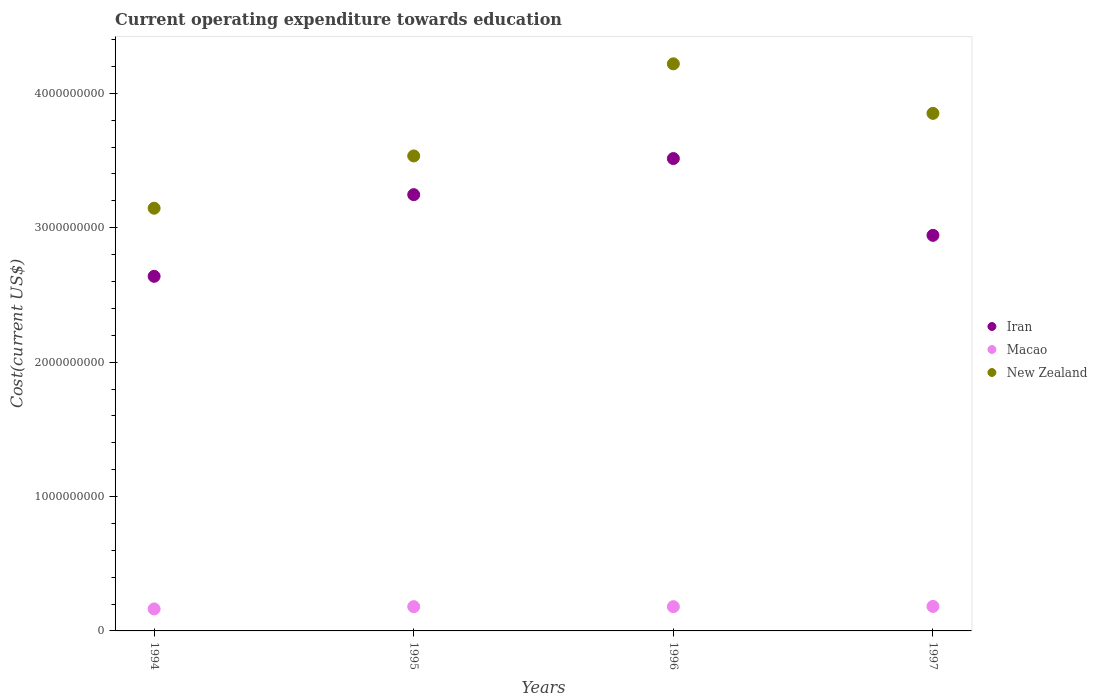What is the expenditure towards education in Macao in 1996?
Make the answer very short. 1.80e+08. Across all years, what is the maximum expenditure towards education in Iran?
Keep it short and to the point. 3.51e+09. Across all years, what is the minimum expenditure towards education in Macao?
Your answer should be very brief. 1.64e+08. What is the total expenditure towards education in New Zealand in the graph?
Your answer should be very brief. 1.48e+1. What is the difference between the expenditure towards education in New Zealand in 1994 and that in 1995?
Offer a terse response. -3.89e+08. What is the difference between the expenditure towards education in Macao in 1994 and the expenditure towards education in Iran in 1997?
Offer a very short reply. -2.78e+09. What is the average expenditure towards education in New Zealand per year?
Offer a terse response. 3.69e+09. In the year 1997, what is the difference between the expenditure towards education in Iran and expenditure towards education in New Zealand?
Your answer should be very brief. -9.08e+08. What is the ratio of the expenditure towards education in New Zealand in 1995 to that in 1996?
Ensure brevity in your answer.  0.84. What is the difference between the highest and the second highest expenditure towards education in New Zealand?
Provide a succinct answer. 3.69e+08. What is the difference between the highest and the lowest expenditure towards education in Iran?
Ensure brevity in your answer.  8.76e+08. In how many years, is the expenditure towards education in Iran greater than the average expenditure towards education in Iran taken over all years?
Make the answer very short. 2. Is the sum of the expenditure towards education in New Zealand in 1994 and 1996 greater than the maximum expenditure towards education in Iran across all years?
Keep it short and to the point. Yes. Is it the case that in every year, the sum of the expenditure towards education in New Zealand and expenditure towards education in Iran  is greater than the expenditure towards education in Macao?
Your answer should be compact. Yes. Does the expenditure towards education in Macao monotonically increase over the years?
Offer a very short reply. No. How many years are there in the graph?
Ensure brevity in your answer.  4. Does the graph contain grids?
Offer a terse response. No. How many legend labels are there?
Offer a terse response. 3. What is the title of the graph?
Give a very brief answer. Current operating expenditure towards education. What is the label or title of the Y-axis?
Give a very brief answer. Cost(current US$). What is the Cost(current US$) in Iran in 1994?
Offer a terse response. 2.64e+09. What is the Cost(current US$) of Macao in 1994?
Ensure brevity in your answer.  1.64e+08. What is the Cost(current US$) in New Zealand in 1994?
Offer a very short reply. 3.15e+09. What is the Cost(current US$) in Iran in 1995?
Your response must be concise. 3.25e+09. What is the Cost(current US$) in Macao in 1995?
Provide a short and direct response. 1.81e+08. What is the Cost(current US$) of New Zealand in 1995?
Provide a short and direct response. 3.53e+09. What is the Cost(current US$) of Iran in 1996?
Make the answer very short. 3.51e+09. What is the Cost(current US$) of Macao in 1996?
Keep it short and to the point. 1.80e+08. What is the Cost(current US$) of New Zealand in 1996?
Provide a succinct answer. 4.22e+09. What is the Cost(current US$) in Iran in 1997?
Provide a succinct answer. 2.94e+09. What is the Cost(current US$) of Macao in 1997?
Provide a succinct answer. 1.82e+08. What is the Cost(current US$) of New Zealand in 1997?
Offer a very short reply. 3.85e+09. Across all years, what is the maximum Cost(current US$) in Iran?
Ensure brevity in your answer.  3.51e+09. Across all years, what is the maximum Cost(current US$) of Macao?
Give a very brief answer. 1.82e+08. Across all years, what is the maximum Cost(current US$) of New Zealand?
Your response must be concise. 4.22e+09. Across all years, what is the minimum Cost(current US$) in Iran?
Your answer should be compact. 2.64e+09. Across all years, what is the minimum Cost(current US$) in Macao?
Your answer should be very brief. 1.64e+08. Across all years, what is the minimum Cost(current US$) of New Zealand?
Your response must be concise. 3.15e+09. What is the total Cost(current US$) of Iran in the graph?
Give a very brief answer. 1.23e+1. What is the total Cost(current US$) in Macao in the graph?
Offer a terse response. 7.07e+08. What is the total Cost(current US$) in New Zealand in the graph?
Offer a terse response. 1.48e+1. What is the difference between the Cost(current US$) in Iran in 1994 and that in 1995?
Your answer should be very brief. -6.08e+08. What is the difference between the Cost(current US$) of Macao in 1994 and that in 1995?
Give a very brief answer. -1.69e+07. What is the difference between the Cost(current US$) of New Zealand in 1994 and that in 1995?
Offer a very short reply. -3.89e+08. What is the difference between the Cost(current US$) in Iran in 1994 and that in 1996?
Your answer should be very brief. -8.76e+08. What is the difference between the Cost(current US$) in Macao in 1994 and that in 1996?
Your answer should be very brief. -1.68e+07. What is the difference between the Cost(current US$) in New Zealand in 1994 and that in 1996?
Offer a very short reply. -1.07e+09. What is the difference between the Cost(current US$) of Iran in 1994 and that in 1997?
Give a very brief answer. -3.05e+08. What is the difference between the Cost(current US$) in Macao in 1994 and that in 1997?
Ensure brevity in your answer.  -1.85e+07. What is the difference between the Cost(current US$) of New Zealand in 1994 and that in 1997?
Make the answer very short. -7.06e+08. What is the difference between the Cost(current US$) in Iran in 1995 and that in 1996?
Offer a terse response. -2.69e+08. What is the difference between the Cost(current US$) of Macao in 1995 and that in 1996?
Provide a short and direct response. 9.88e+04. What is the difference between the Cost(current US$) of New Zealand in 1995 and that in 1996?
Provide a short and direct response. -6.85e+08. What is the difference between the Cost(current US$) of Iran in 1995 and that in 1997?
Offer a terse response. 3.03e+08. What is the difference between the Cost(current US$) in Macao in 1995 and that in 1997?
Offer a terse response. -1.66e+06. What is the difference between the Cost(current US$) of New Zealand in 1995 and that in 1997?
Provide a short and direct response. -3.17e+08. What is the difference between the Cost(current US$) in Iran in 1996 and that in 1997?
Provide a short and direct response. 5.71e+08. What is the difference between the Cost(current US$) in Macao in 1996 and that in 1997?
Give a very brief answer. -1.76e+06. What is the difference between the Cost(current US$) in New Zealand in 1996 and that in 1997?
Your answer should be very brief. 3.69e+08. What is the difference between the Cost(current US$) in Iran in 1994 and the Cost(current US$) in Macao in 1995?
Offer a very short reply. 2.46e+09. What is the difference between the Cost(current US$) of Iran in 1994 and the Cost(current US$) of New Zealand in 1995?
Provide a succinct answer. -8.96e+08. What is the difference between the Cost(current US$) in Macao in 1994 and the Cost(current US$) in New Zealand in 1995?
Offer a very short reply. -3.37e+09. What is the difference between the Cost(current US$) of Iran in 1994 and the Cost(current US$) of Macao in 1996?
Provide a succinct answer. 2.46e+09. What is the difference between the Cost(current US$) in Iran in 1994 and the Cost(current US$) in New Zealand in 1996?
Ensure brevity in your answer.  -1.58e+09. What is the difference between the Cost(current US$) in Macao in 1994 and the Cost(current US$) in New Zealand in 1996?
Provide a succinct answer. -4.06e+09. What is the difference between the Cost(current US$) in Iran in 1994 and the Cost(current US$) in Macao in 1997?
Keep it short and to the point. 2.46e+09. What is the difference between the Cost(current US$) in Iran in 1994 and the Cost(current US$) in New Zealand in 1997?
Offer a very short reply. -1.21e+09. What is the difference between the Cost(current US$) in Macao in 1994 and the Cost(current US$) in New Zealand in 1997?
Make the answer very short. -3.69e+09. What is the difference between the Cost(current US$) of Iran in 1995 and the Cost(current US$) of Macao in 1996?
Keep it short and to the point. 3.07e+09. What is the difference between the Cost(current US$) in Iran in 1995 and the Cost(current US$) in New Zealand in 1996?
Keep it short and to the point. -9.73e+08. What is the difference between the Cost(current US$) of Macao in 1995 and the Cost(current US$) of New Zealand in 1996?
Make the answer very short. -4.04e+09. What is the difference between the Cost(current US$) in Iran in 1995 and the Cost(current US$) in Macao in 1997?
Offer a terse response. 3.06e+09. What is the difference between the Cost(current US$) in Iran in 1995 and the Cost(current US$) in New Zealand in 1997?
Your answer should be compact. -6.05e+08. What is the difference between the Cost(current US$) of Macao in 1995 and the Cost(current US$) of New Zealand in 1997?
Your answer should be very brief. -3.67e+09. What is the difference between the Cost(current US$) in Iran in 1996 and the Cost(current US$) in Macao in 1997?
Give a very brief answer. 3.33e+09. What is the difference between the Cost(current US$) of Iran in 1996 and the Cost(current US$) of New Zealand in 1997?
Give a very brief answer. -3.36e+08. What is the difference between the Cost(current US$) of Macao in 1996 and the Cost(current US$) of New Zealand in 1997?
Keep it short and to the point. -3.67e+09. What is the average Cost(current US$) in Iran per year?
Provide a short and direct response. 3.09e+09. What is the average Cost(current US$) of Macao per year?
Offer a terse response. 1.77e+08. What is the average Cost(current US$) of New Zealand per year?
Give a very brief answer. 3.69e+09. In the year 1994, what is the difference between the Cost(current US$) in Iran and Cost(current US$) in Macao?
Your response must be concise. 2.47e+09. In the year 1994, what is the difference between the Cost(current US$) in Iran and Cost(current US$) in New Zealand?
Your answer should be compact. -5.07e+08. In the year 1994, what is the difference between the Cost(current US$) in Macao and Cost(current US$) in New Zealand?
Make the answer very short. -2.98e+09. In the year 1995, what is the difference between the Cost(current US$) of Iran and Cost(current US$) of Macao?
Your answer should be very brief. 3.07e+09. In the year 1995, what is the difference between the Cost(current US$) in Iran and Cost(current US$) in New Zealand?
Make the answer very short. -2.88e+08. In the year 1995, what is the difference between the Cost(current US$) of Macao and Cost(current US$) of New Zealand?
Your answer should be very brief. -3.35e+09. In the year 1996, what is the difference between the Cost(current US$) of Iran and Cost(current US$) of Macao?
Offer a terse response. 3.33e+09. In the year 1996, what is the difference between the Cost(current US$) of Iran and Cost(current US$) of New Zealand?
Your answer should be compact. -7.05e+08. In the year 1996, what is the difference between the Cost(current US$) in Macao and Cost(current US$) in New Zealand?
Your response must be concise. -4.04e+09. In the year 1997, what is the difference between the Cost(current US$) of Iran and Cost(current US$) of Macao?
Provide a succinct answer. 2.76e+09. In the year 1997, what is the difference between the Cost(current US$) of Iran and Cost(current US$) of New Zealand?
Keep it short and to the point. -9.08e+08. In the year 1997, what is the difference between the Cost(current US$) in Macao and Cost(current US$) in New Zealand?
Make the answer very short. -3.67e+09. What is the ratio of the Cost(current US$) in Iran in 1994 to that in 1995?
Give a very brief answer. 0.81. What is the ratio of the Cost(current US$) in Macao in 1994 to that in 1995?
Ensure brevity in your answer.  0.91. What is the ratio of the Cost(current US$) in New Zealand in 1994 to that in 1995?
Provide a succinct answer. 0.89. What is the ratio of the Cost(current US$) in Iran in 1994 to that in 1996?
Keep it short and to the point. 0.75. What is the ratio of the Cost(current US$) in Macao in 1994 to that in 1996?
Your response must be concise. 0.91. What is the ratio of the Cost(current US$) in New Zealand in 1994 to that in 1996?
Make the answer very short. 0.75. What is the ratio of the Cost(current US$) of Iran in 1994 to that in 1997?
Give a very brief answer. 0.9. What is the ratio of the Cost(current US$) in Macao in 1994 to that in 1997?
Your response must be concise. 0.9. What is the ratio of the Cost(current US$) of New Zealand in 1994 to that in 1997?
Provide a short and direct response. 0.82. What is the ratio of the Cost(current US$) in Iran in 1995 to that in 1996?
Offer a terse response. 0.92. What is the ratio of the Cost(current US$) of New Zealand in 1995 to that in 1996?
Your answer should be compact. 0.84. What is the ratio of the Cost(current US$) of Iran in 1995 to that in 1997?
Ensure brevity in your answer.  1.1. What is the ratio of the Cost(current US$) in Macao in 1995 to that in 1997?
Ensure brevity in your answer.  0.99. What is the ratio of the Cost(current US$) of New Zealand in 1995 to that in 1997?
Keep it short and to the point. 0.92. What is the ratio of the Cost(current US$) in Iran in 1996 to that in 1997?
Provide a succinct answer. 1.19. What is the ratio of the Cost(current US$) in New Zealand in 1996 to that in 1997?
Ensure brevity in your answer.  1.1. What is the difference between the highest and the second highest Cost(current US$) of Iran?
Make the answer very short. 2.69e+08. What is the difference between the highest and the second highest Cost(current US$) of Macao?
Give a very brief answer. 1.66e+06. What is the difference between the highest and the second highest Cost(current US$) of New Zealand?
Offer a terse response. 3.69e+08. What is the difference between the highest and the lowest Cost(current US$) in Iran?
Provide a succinct answer. 8.76e+08. What is the difference between the highest and the lowest Cost(current US$) in Macao?
Your answer should be compact. 1.85e+07. What is the difference between the highest and the lowest Cost(current US$) in New Zealand?
Provide a short and direct response. 1.07e+09. 